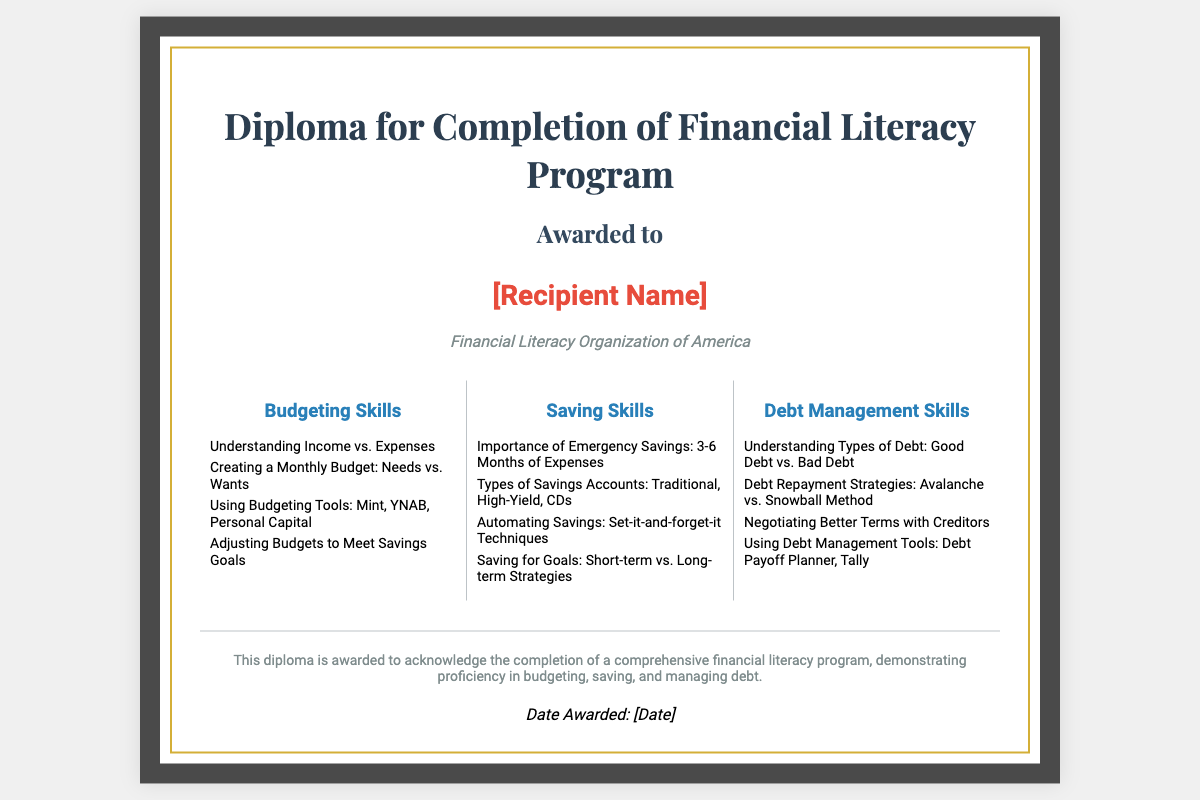What is the title of the diploma? The title of the diploma is prominently displayed at the top of the document.
Answer: Diploma for Completion of Financial Literacy Program Who awarded the diploma? The organization awarding the diploma is mentioned in the document near the recipient's name.
Answer: Financial Literacy Organization of America What is the focus of the skills taught in the program? The sections in the document specify the key areas of focus for the skills.
Answer: Budgeting, Saving, and Debt Management Skills What is one type of savings account mentioned? The document lists the types of savings accounts in the Savings Skills section.
Answer: High-Yield How many months of expenses should be in emergency savings? The importance of emergency savings suggests a specific number of months.
Answer: 3-6 Months What method is used for debt repayment strategy in the document? The types of debt repayment strategies are clearly mentioned in the Debt Management Skills section.
Answer: Avalanche vs. Snowball Method What is the main purpose of the diploma? The footer in the document summarizes the main purpose of awarding the diploma.
Answer: To acknowledge the completion of a comprehensive financial literacy program When is the diploma awarded? The date awarded is indicated at the bottom of the document.
Answer: [Date] 